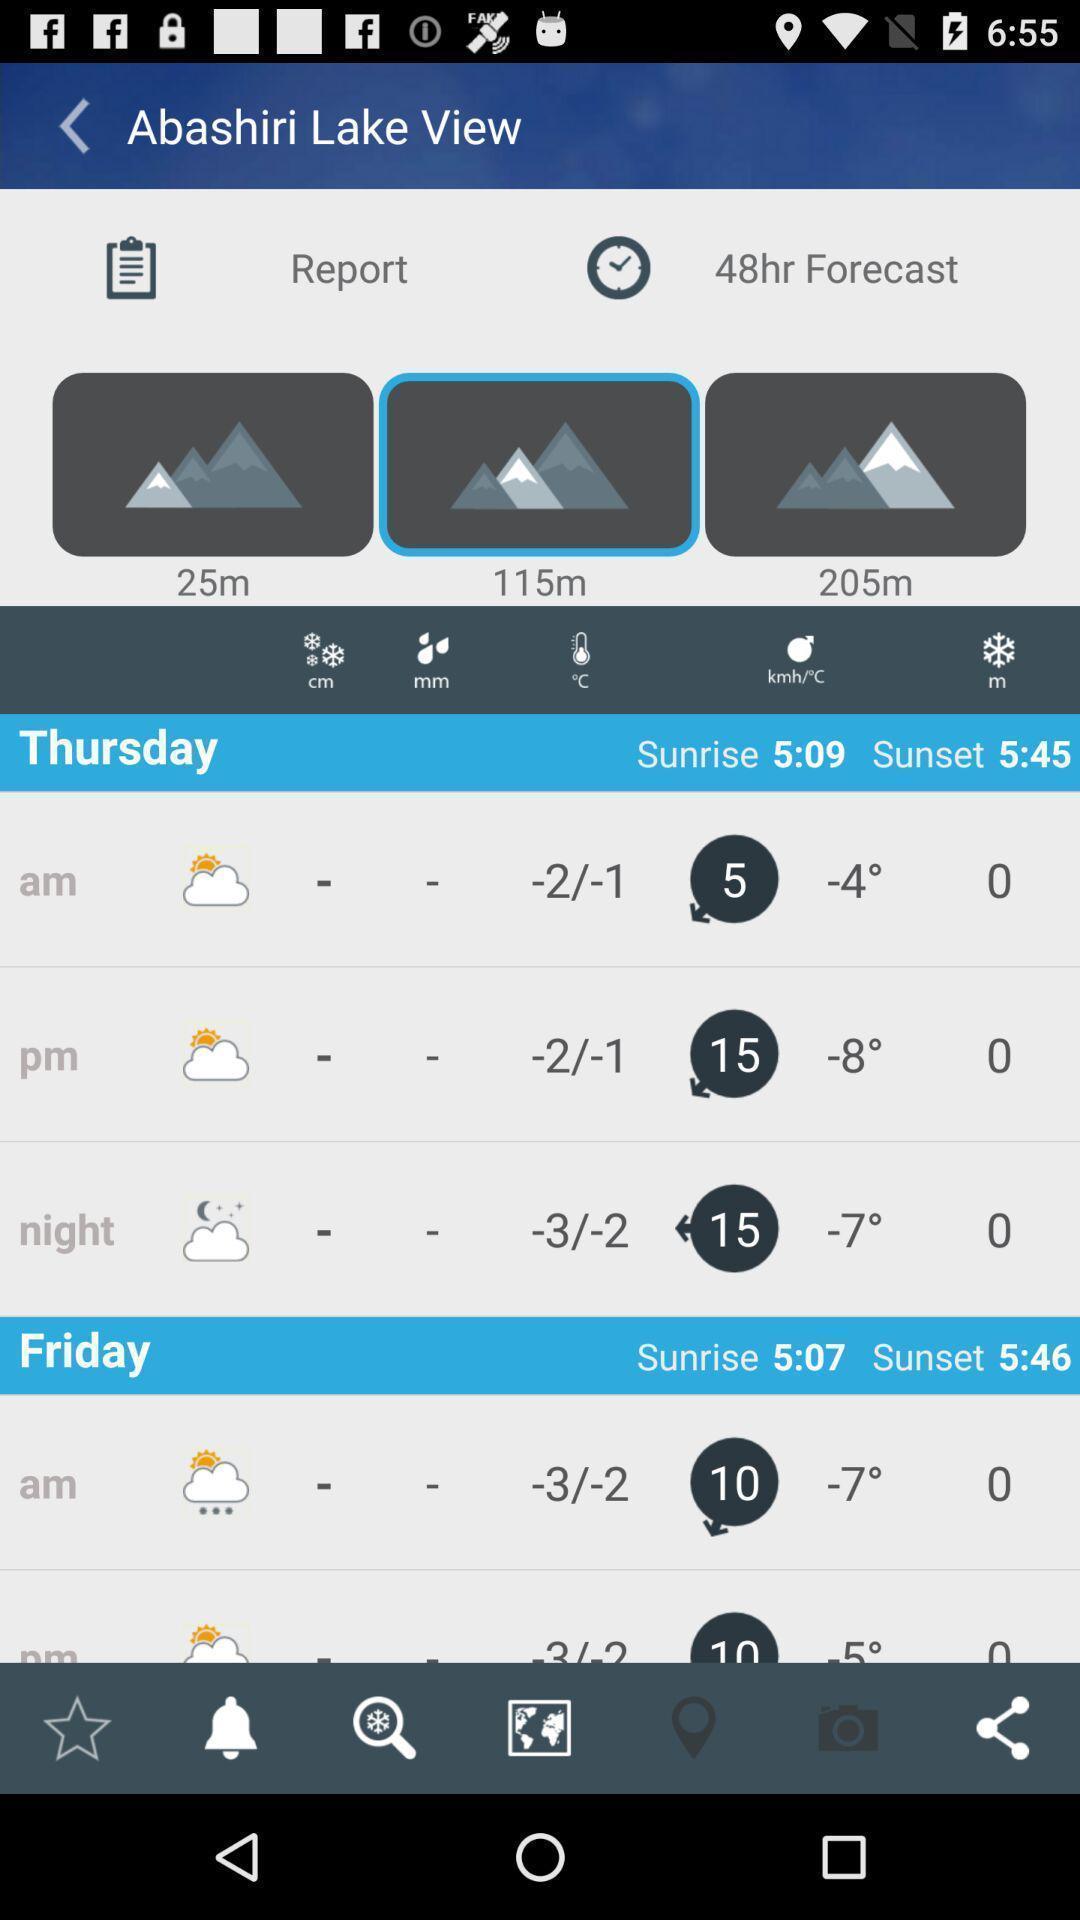Explain what's happening in this screen capture. Various weather forecast of a place displayed. 